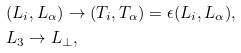Convert formula to latex. <formula><loc_0><loc_0><loc_500><loc_500>& ( L _ { i } , L _ { \alpha } ) \rightarrow ( T _ { i } , T _ { \alpha } ) = \epsilon ( L _ { i } , L _ { \alpha } ) , \\ & L _ { 3 } \rightarrow L _ { \perp } ,</formula> 